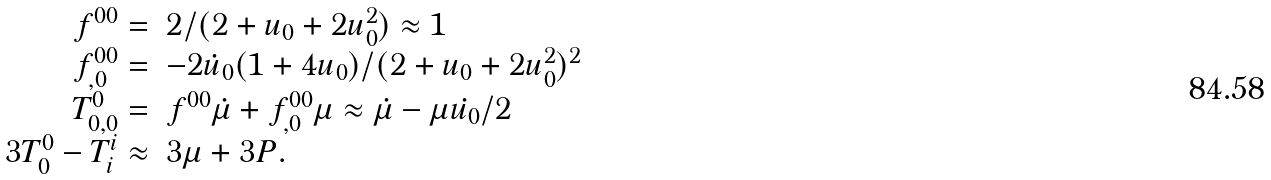<formula> <loc_0><loc_0><loc_500><loc_500>\begin{array} { r l } f ^ { 0 0 } = & 2 / ( 2 + u _ { 0 } + 2 u _ { 0 } ^ { 2 } ) \approx 1 \\ f ^ { 0 0 } _ { , 0 } = & - 2 \dot { u } _ { 0 } ( 1 + 4 u _ { 0 } ) / ( 2 + u _ { 0 } + 2 u _ { 0 } ^ { 2 } ) ^ { 2 } \\ T ^ { 0 } _ { 0 , 0 } = & f ^ { 0 0 } \dot { \mu } + f ^ { 0 0 } _ { , 0 } \mu \approx \dot { \mu } - \mu \dot { u _ { 0 } } / 2 \\ 3 T ^ { 0 } _ { 0 } - T ^ { i } _ { i } \approx & 3 \mu + 3 P . \end{array}</formula> 